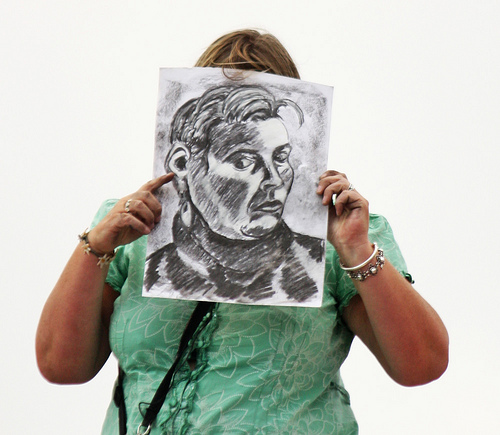<image>
Is there a drawing on the woman? No. The drawing is not positioned on the woman. They may be near each other, but the drawing is not supported by or resting on top of the woman. Is there a drawing in front of the ring? No. The drawing is not in front of the ring. The spatial positioning shows a different relationship between these objects. 